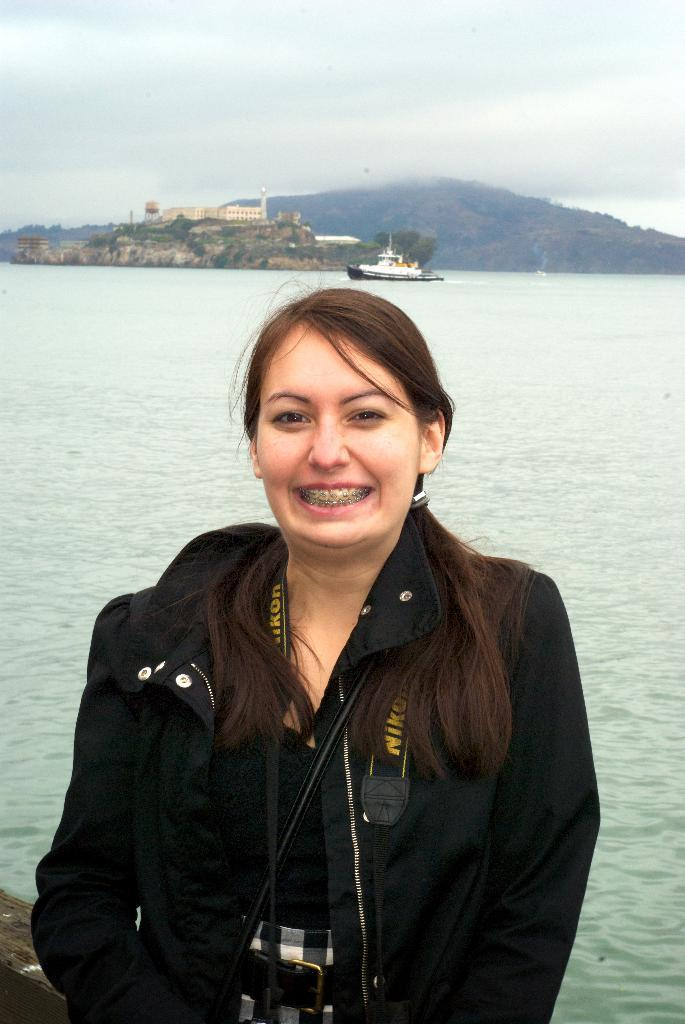Who is present in the image? There is a woman standing in the image. What can be seen in the background of the image? There is a ship visible in the image. Where is the ship located in relation to the water? The ship is on the water surface. What type of ice can be seen melting on the woman's head in the image? There is no ice present on the woman's head in the image. 